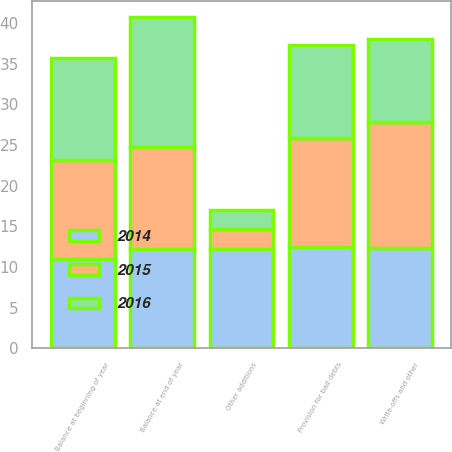Convert chart to OTSL. <chart><loc_0><loc_0><loc_500><loc_500><stacked_bar_chart><ecel><fcel>Balance at beginning of year<fcel>Provision for bad debts<fcel>Other additions<fcel>Write-offs and other<fcel>Balance at end of year<nl><fcel>2016<fcel>12.5<fcel>11.4<fcel>2.4<fcel>10.3<fcel>16<nl><fcel>2015<fcel>12.2<fcel>13.4<fcel>2.4<fcel>15.5<fcel>12.5<nl><fcel>2014<fcel>11<fcel>12.5<fcel>12.25<fcel>12.3<fcel>12.2<nl></chart> 